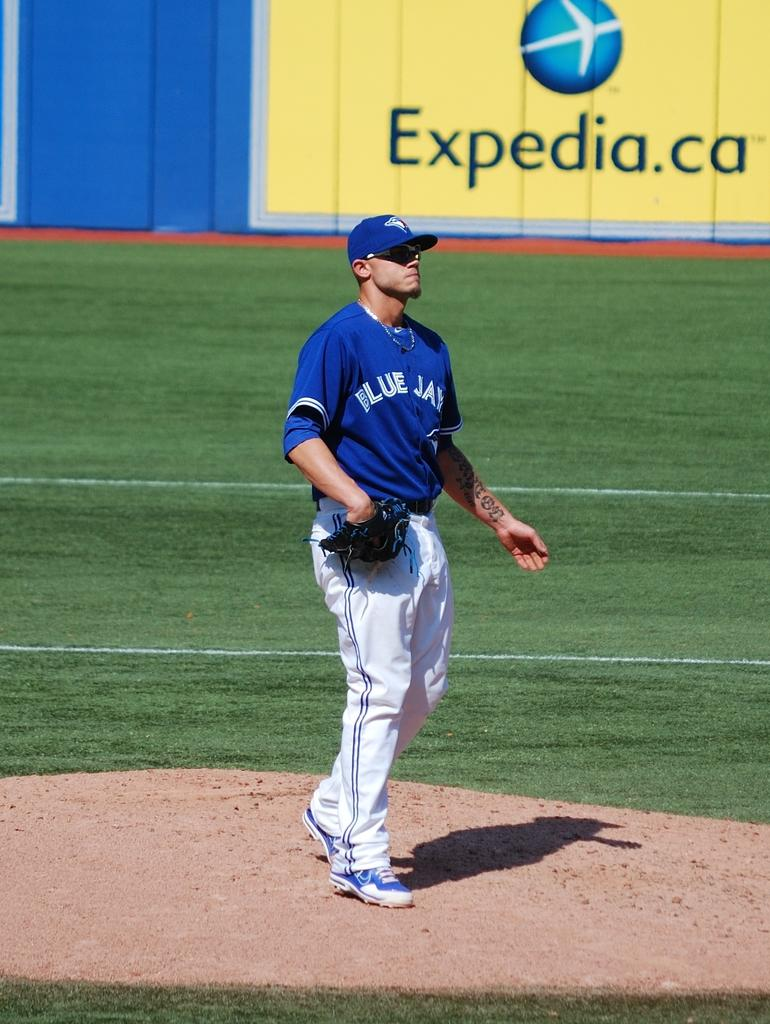<image>
Share a concise interpretation of the image provided. A baseball pitcher is standing in front of an ad for expedia.ca. 